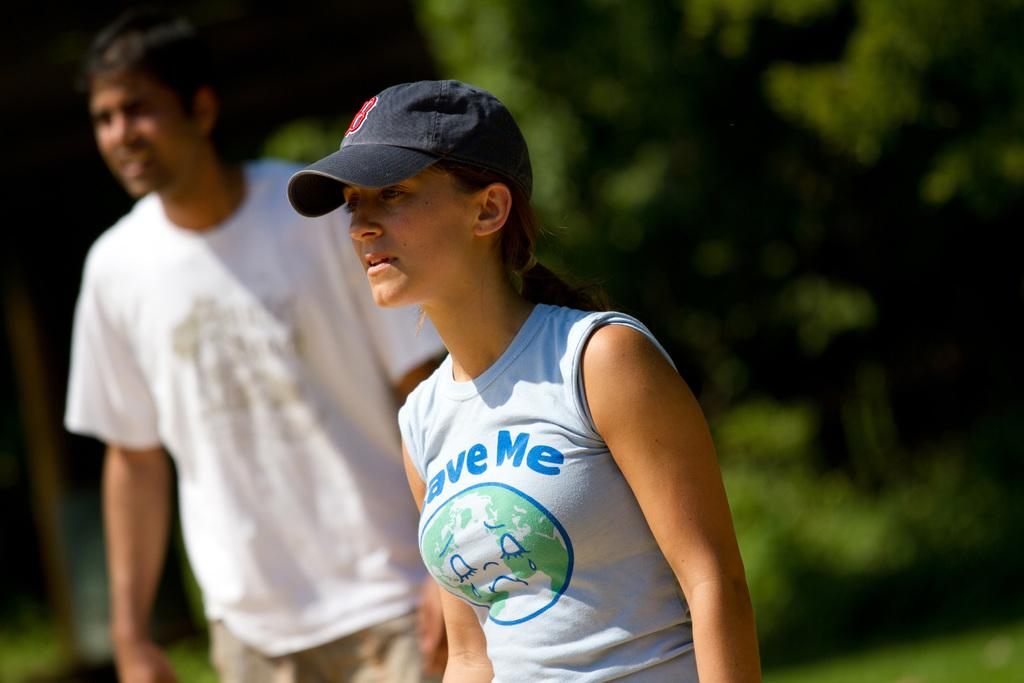<image>
Give a short and clear explanation of the subsequent image. A woman with a tank top that reads save me also wears a cap. 